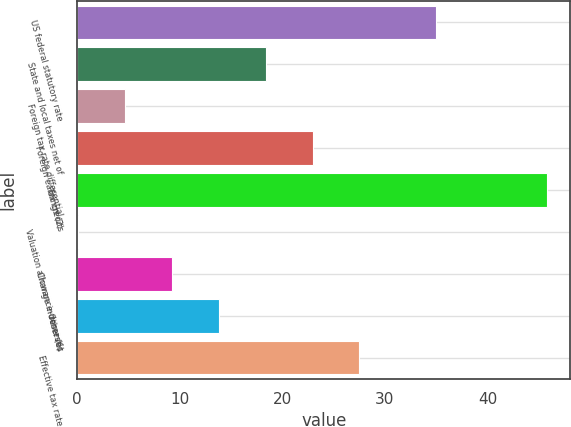Convert chart to OTSL. <chart><loc_0><loc_0><loc_500><loc_500><bar_chart><fcel>US federal statutory rate<fcel>State and local taxes net of<fcel>Foreign tax rate differential<fcel>Foreign earnings (2)<fcel>Tax credits<fcel>Valuation allowance-domestic<fcel>Change in reserves<fcel>Other (6)<fcel>Effective tax rate<nl><fcel>35<fcel>18.38<fcel>4.67<fcel>22.95<fcel>45.8<fcel>0.1<fcel>9.24<fcel>13.81<fcel>27.52<nl></chart> 